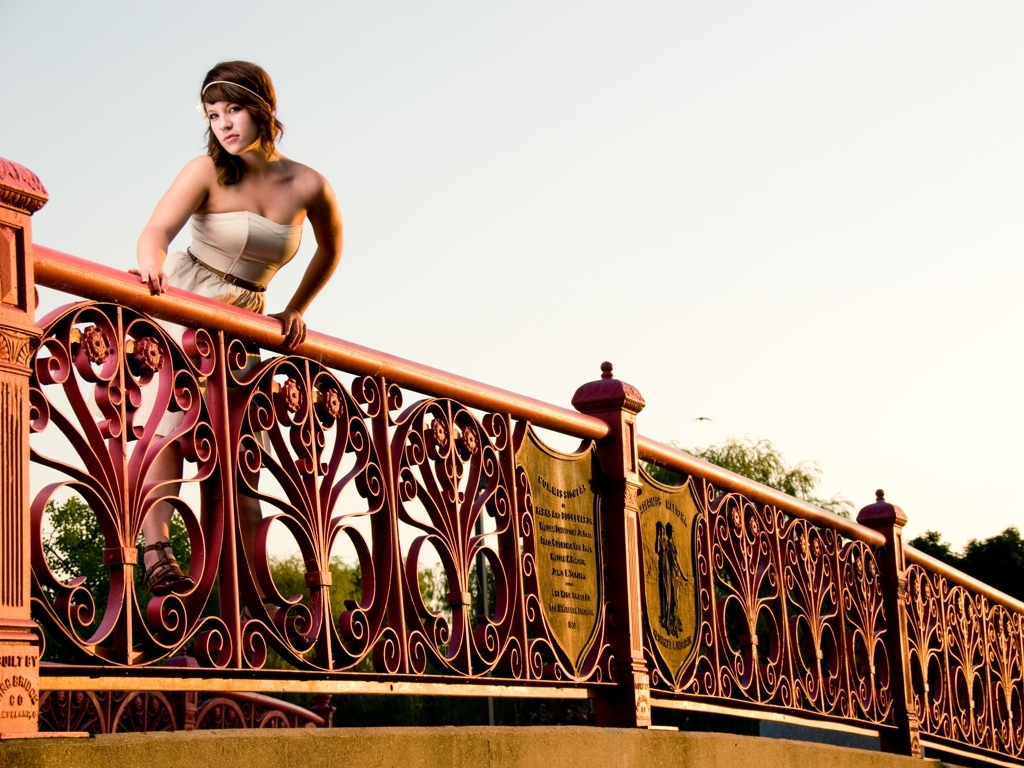How well are the details of the woman's movements presented? The details of the woman's movements are captured with a high degree of clarity and sharpness, conveying a sense of poised motion as she leans over the ornate railing. The subtle tension in her posture suggests a moment frozen in time, emphasizing dynamism and elegance within the still image. 